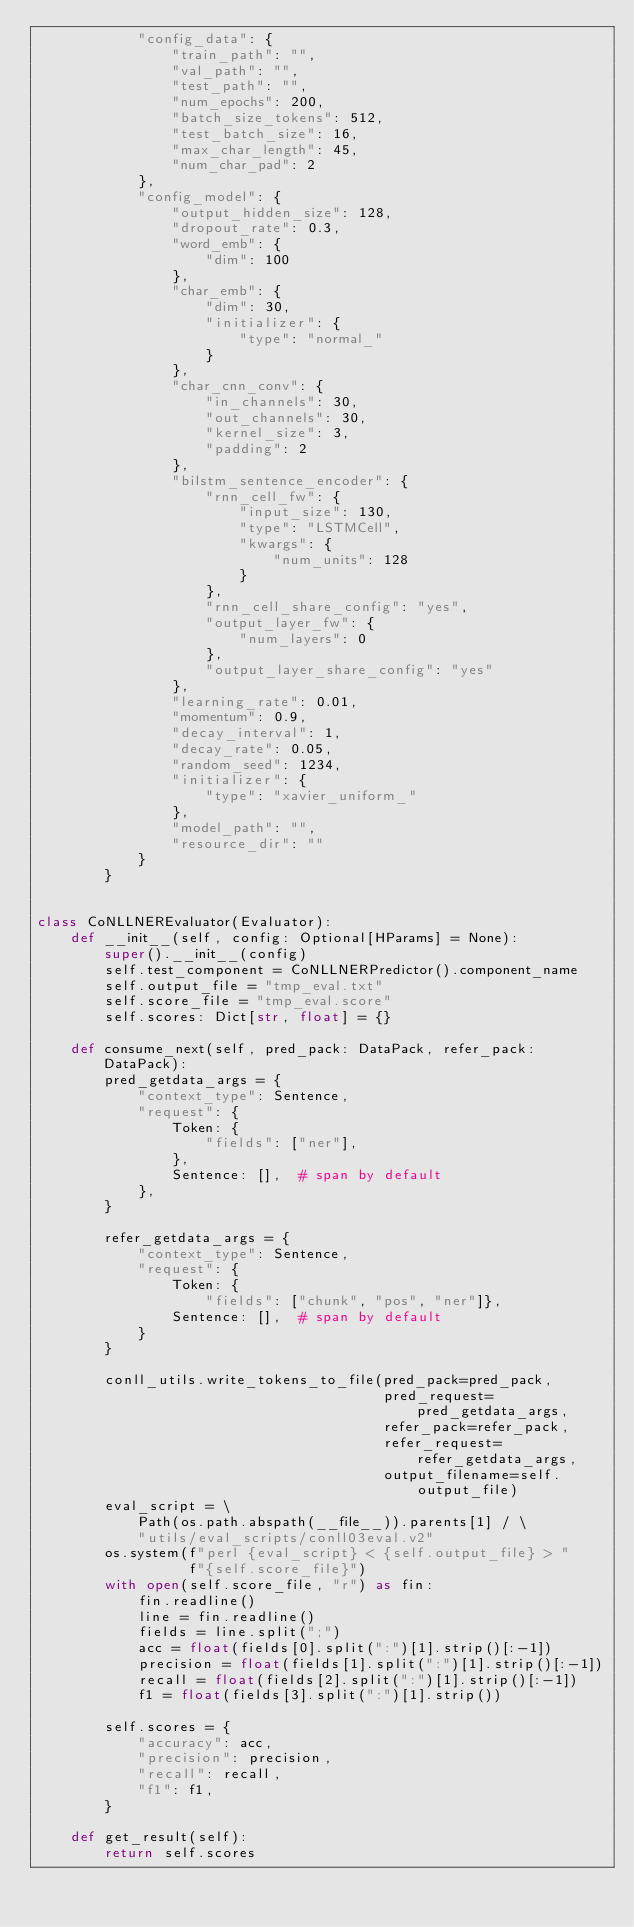Convert code to text. <code><loc_0><loc_0><loc_500><loc_500><_Python_>            "config_data": {
                "train_path": "",
                "val_path": "",
                "test_path": "",
                "num_epochs": 200,
                "batch_size_tokens": 512,
                "test_batch_size": 16,
                "max_char_length": 45,
                "num_char_pad": 2
            },
            "config_model": {
                "output_hidden_size": 128,
                "dropout_rate": 0.3,
                "word_emb": {
                    "dim": 100
                },
                "char_emb": {
                    "dim": 30,
                    "initializer": {
                        "type": "normal_"
                    }
                },
                "char_cnn_conv": {
                    "in_channels": 30,
                    "out_channels": 30,
                    "kernel_size": 3,
                    "padding": 2
                },
                "bilstm_sentence_encoder": {
                    "rnn_cell_fw": {
                        "input_size": 130,
                        "type": "LSTMCell",
                        "kwargs": {
                            "num_units": 128
                        }
                    },
                    "rnn_cell_share_config": "yes",
                    "output_layer_fw": {
                        "num_layers": 0
                    },
                    "output_layer_share_config": "yes"
                },
                "learning_rate": 0.01,
                "momentum": 0.9,
                "decay_interval": 1,
                "decay_rate": 0.05,
                "random_seed": 1234,
                "initializer": {
                    "type": "xavier_uniform_"
                },
                "model_path": "",
                "resource_dir": ""
            }
        }


class CoNLLNEREvaluator(Evaluator):
    def __init__(self, config: Optional[HParams] = None):
        super().__init__(config)
        self.test_component = CoNLLNERPredictor().component_name
        self.output_file = "tmp_eval.txt"
        self.score_file = "tmp_eval.score"
        self.scores: Dict[str, float] = {}

    def consume_next(self, pred_pack: DataPack, refer_pack: DataPack):
        pred_getdata_args = {
            "context_type": Sentence,
            "request": {
                Token: {
                    "fields": ["ner"],
                },
                Sentence: [],  # span by default
            },
        }

        refer_getdata_args = {
            "context_type": Sentence,
            "request": {
                Token: {
                    "fields": ["chunk", "pos", "ner"]},
                Sentence: [],  # span by default
            }
        }

        conll_utils.write_tokens_to_file(pred_pack=pred_pack,
                                         pred_request=pred_getdata_args,
                                         refer_pack=refer_pack,
                                         refer_request=refer_getdata_args,
                                         output_filename=self.output_file)
        eval_script = \
            Path(os.path.abspath(__file__)).parents[1] / \
            "utils/eval_scripts/conll03eval.v2"
        os.system(f"perl {eval_script} < {self.output_file} > "
                  f"{self.score_file}")
        with open(self.score_file, "r") as fin:
            fin.readline()
            line = fin.readline()
            fields = line.split(";")
            acc = float(fields[0].split(":")[1].strip()[:-1])
            precision = float(fields[1].split(":")[1].strip()[:-1])
            recall = float(fields[2].split(":")[1].strip()[:-1])
            f1 = float(fields[3].split(":")[1].strip())

        self.scores = {
            "accuracy": acc,
            "precision": precision,
            "recall": recall,
            "f1": f1,
        }

    def get_result(self):
        return self.scores
</code> 